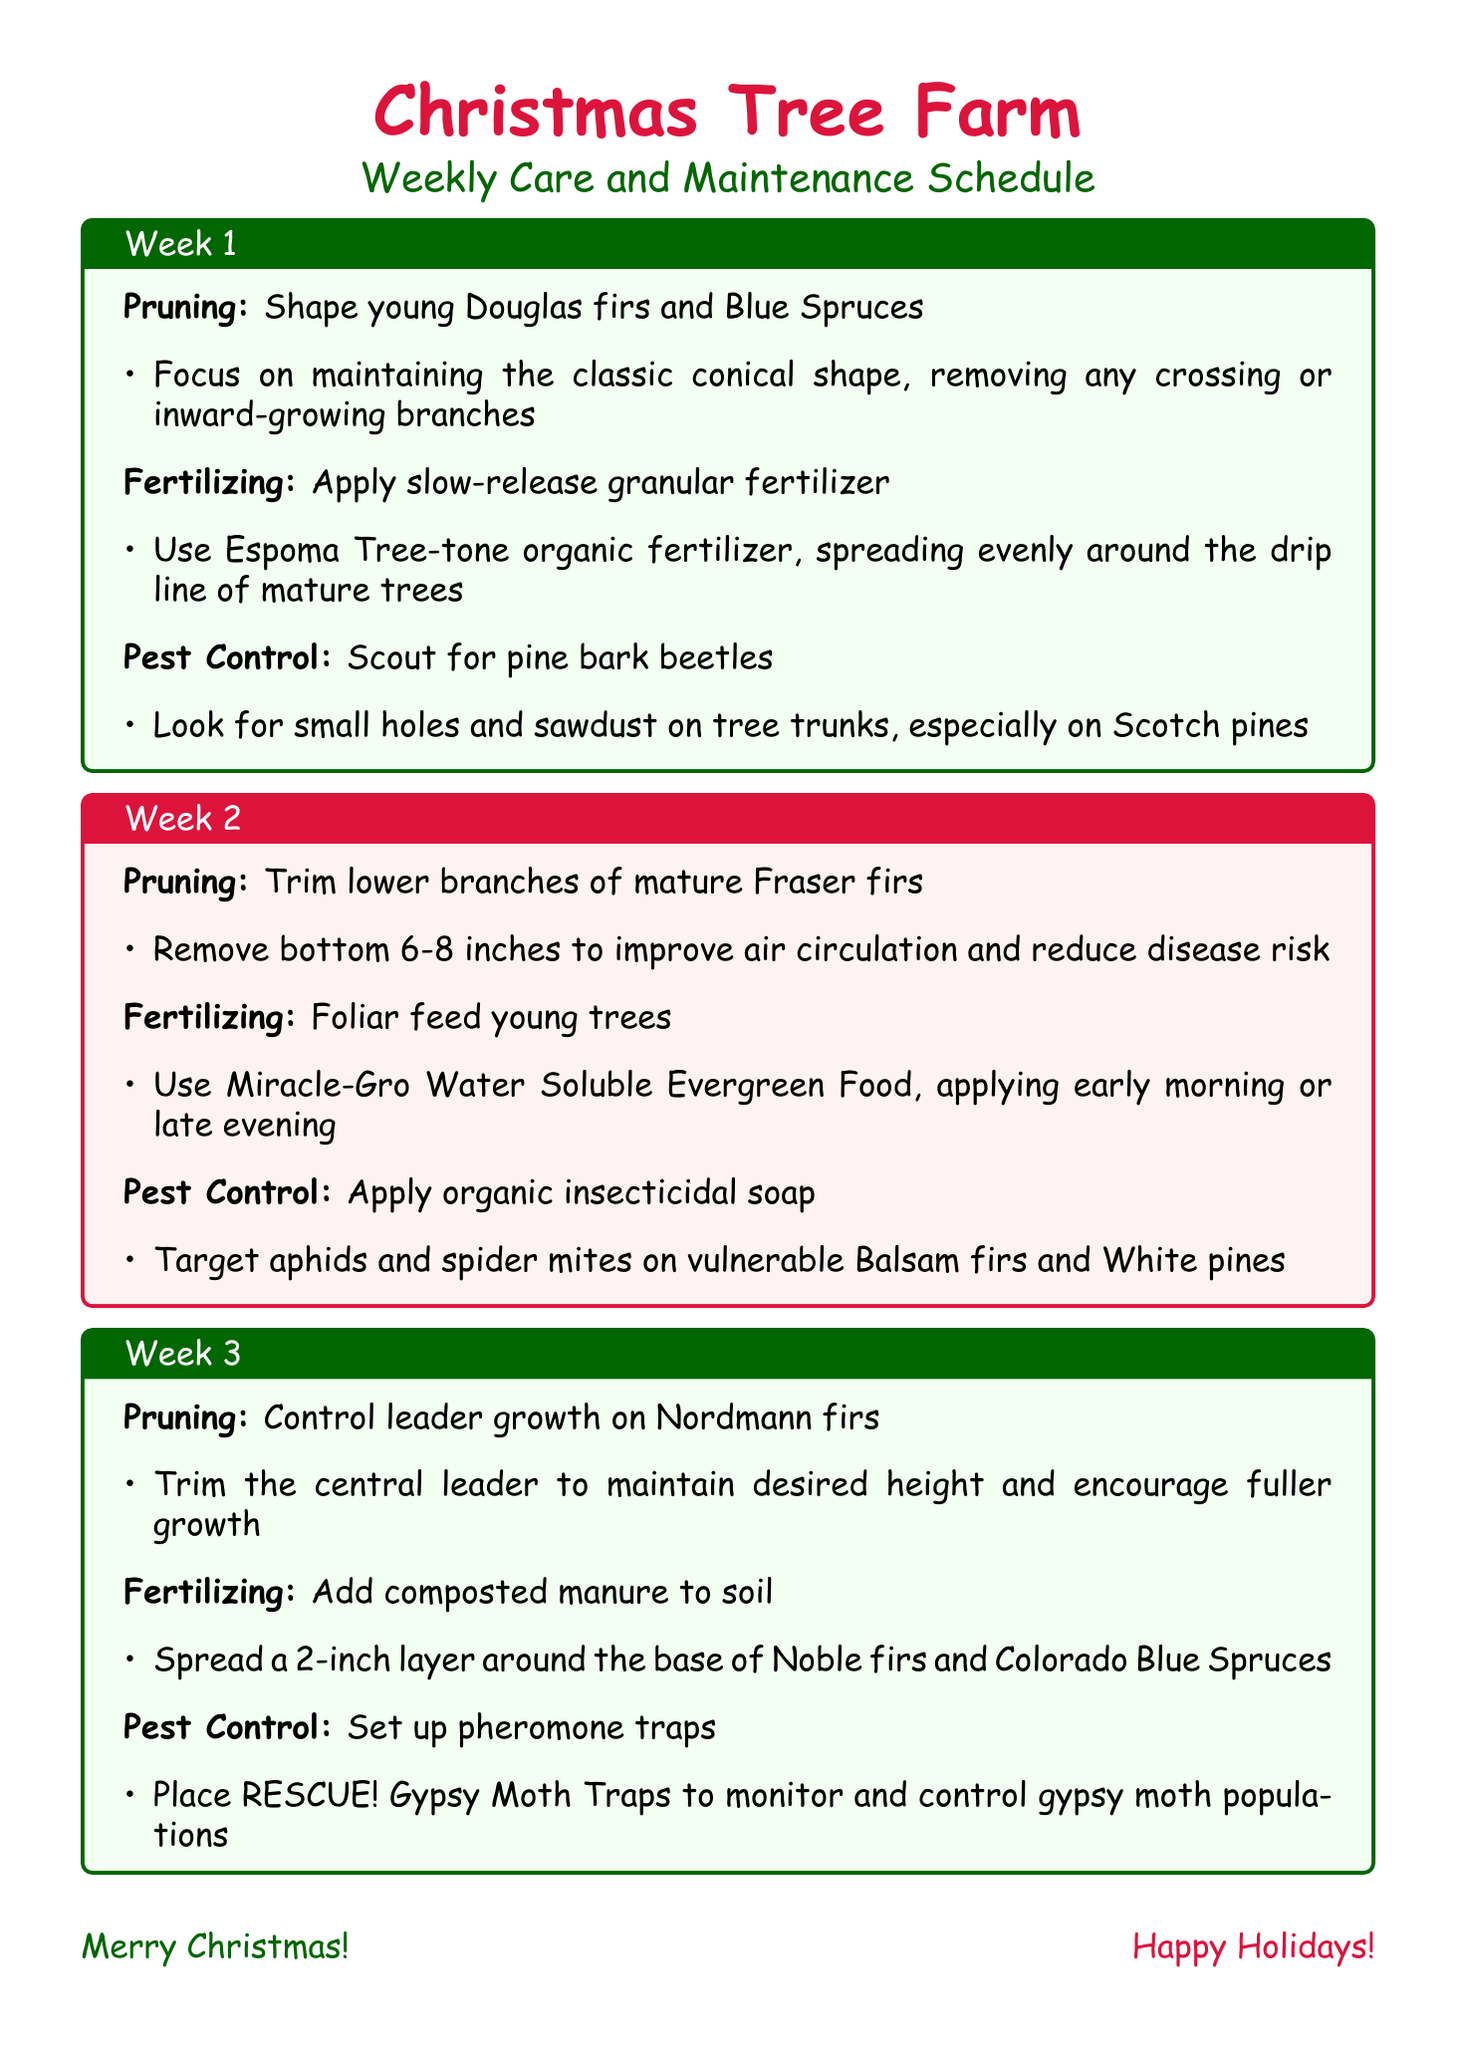what is the first task in week 1? The first task listed under week 1 is to shape young Douglas firs and Blue Spruces.
Answer: Shape young Douglas firs and Blue Spruces which fertilizer is used in week 1? The document specifies the use of Espoma Tree-tone organic fertilizer for fertilizing in week 1.
Answer: Espoma Tree-tone organic fertilizer how many inches should be trimmed from Fraser firs in week 2? The week 2 schedule states to remove the bottom 6-8 inches from Fraser firs.
Answer: 6-8 inches what is the main pest control action in week 3? The focus of pest control in week 3 is to set up pheromone traps.
Answer: Set up pheromone traps which trees should have dead branches removed in week 4? The trees specified for removing dead or diseased branches in week 4 are Concolor firs and Eastern White pines.
Answer: Concolor firs and Eastern White pines what should be monitored for needle cast disease? The document indicates that Blue Spruces should be monitored for signs of needle cast disease.
Answer: Blue Spruces how many weeks are included in the schedule? The document outlines tasks for four weeks.
Answer: Four weeks who is the tree pathologist listed in emergency contacts? The emergency contact for tree pathology is Dr. Elizabeth Pine.
Answer: Dr. Elizabeth Pine 